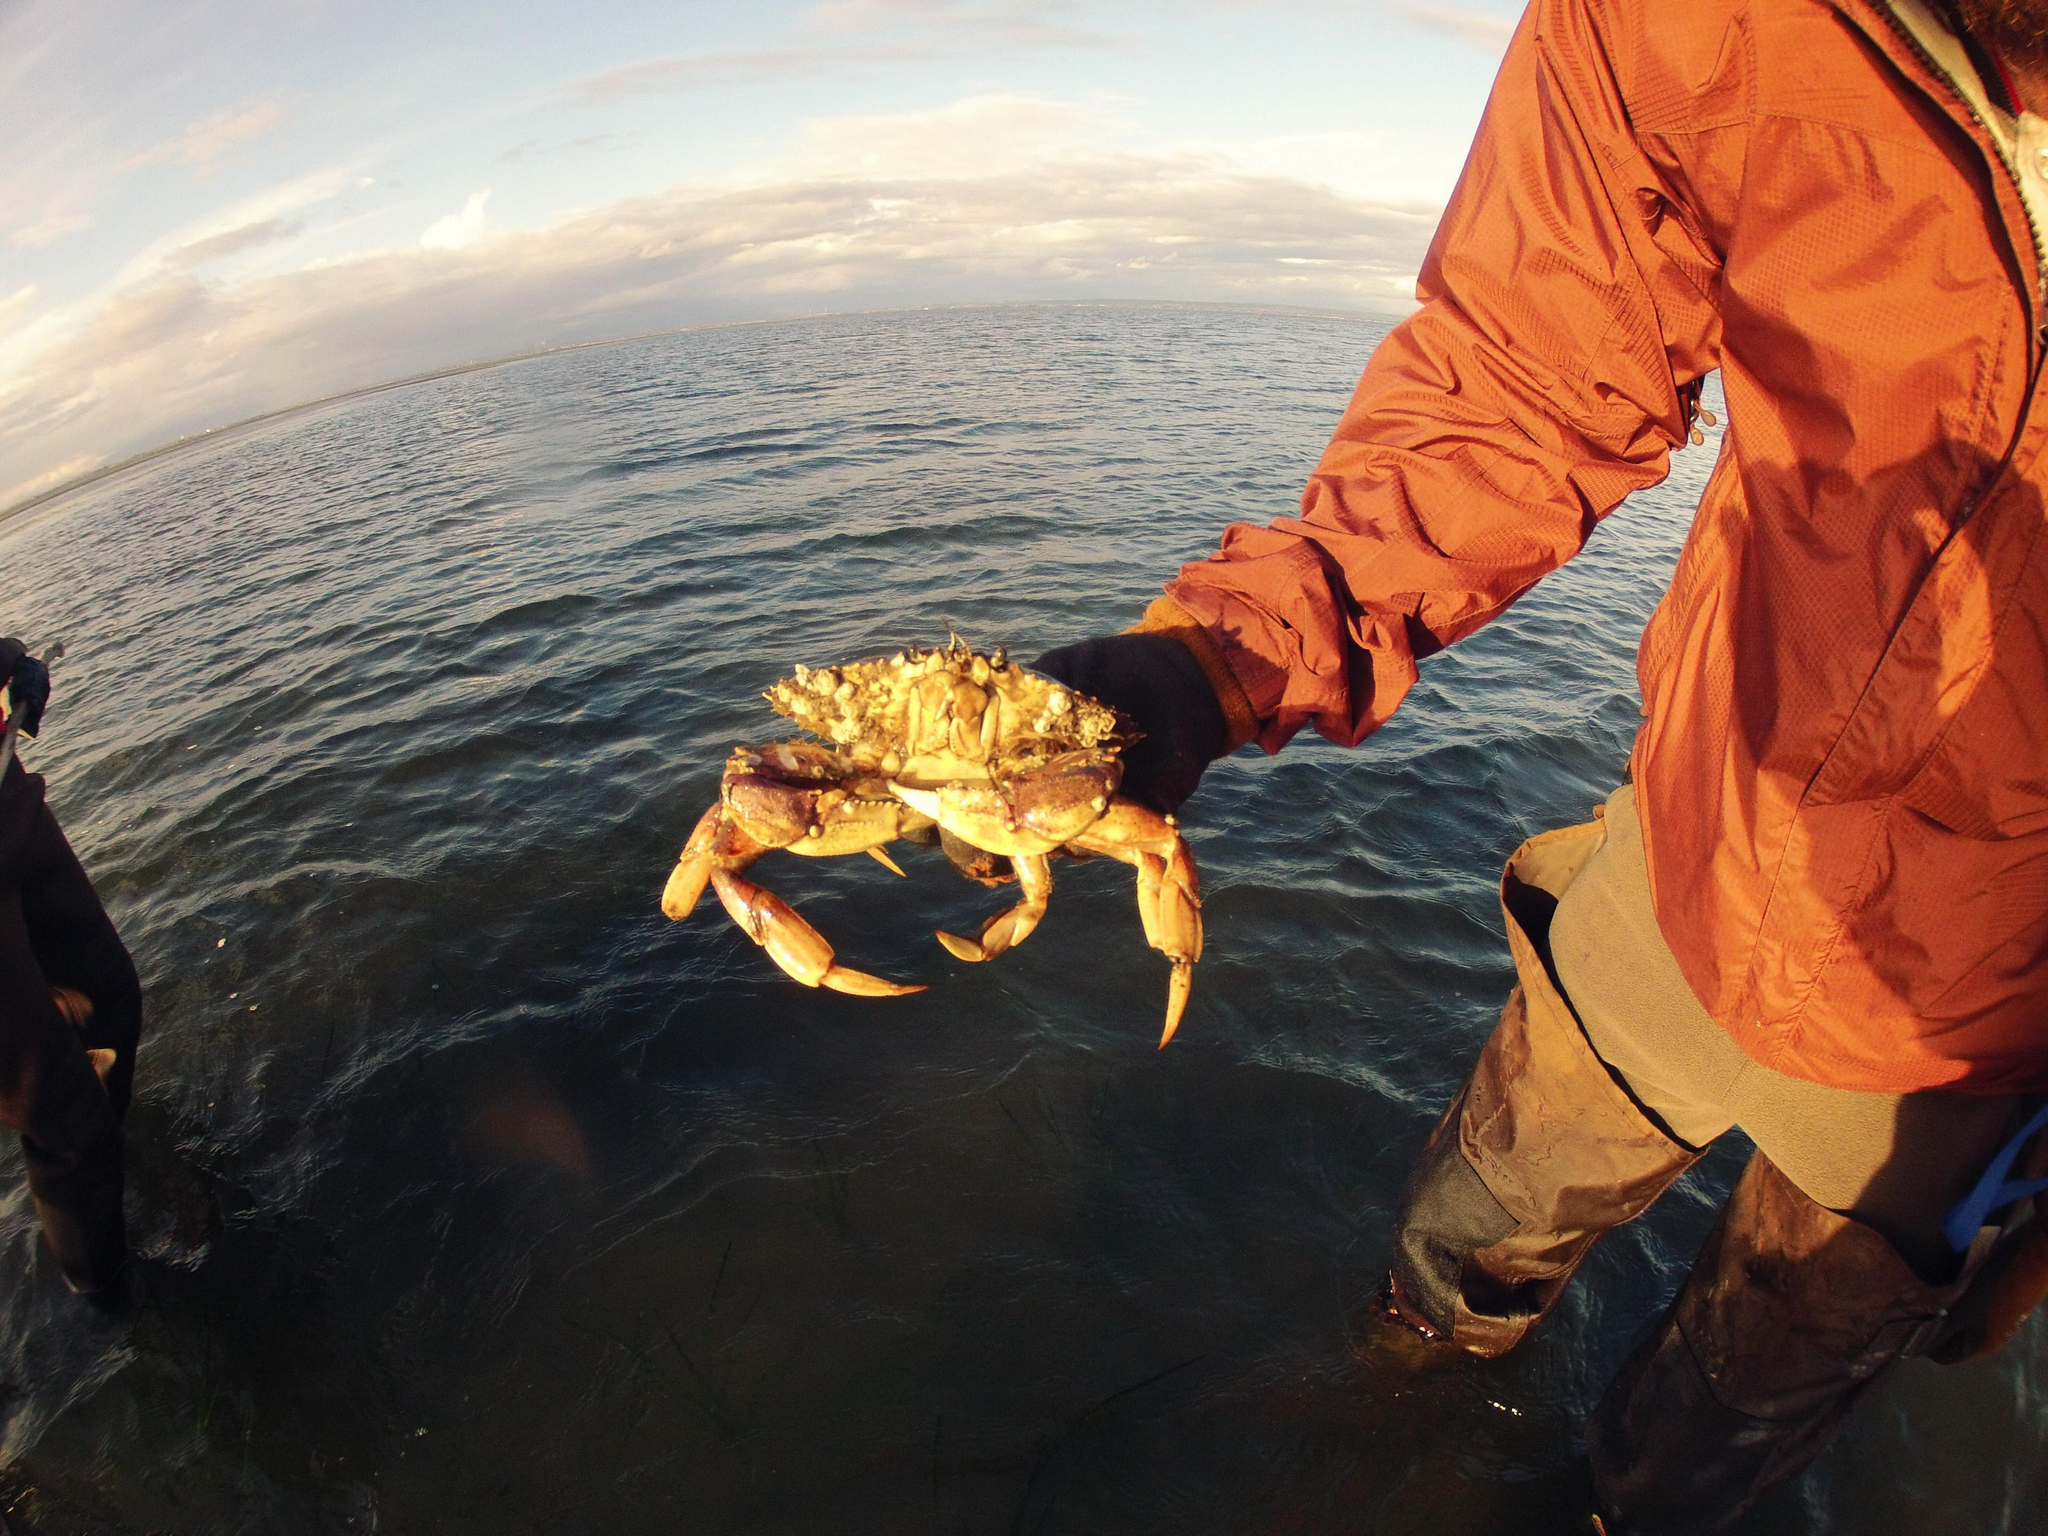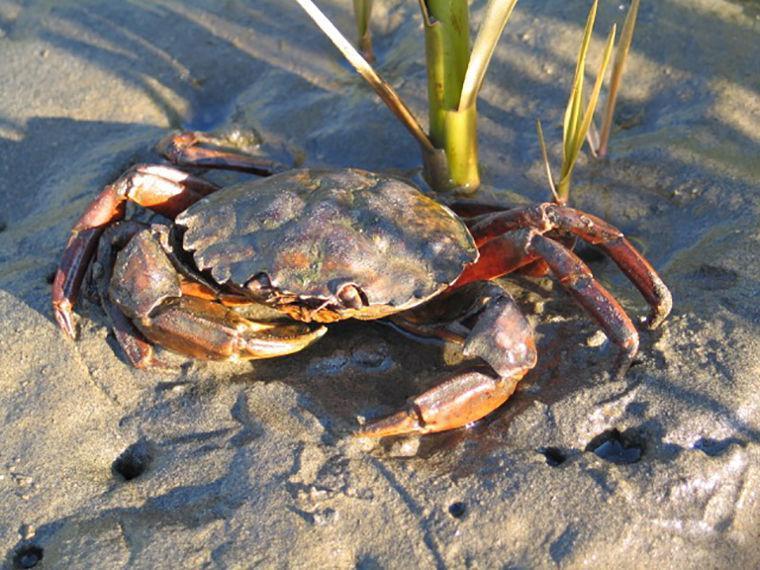The first image is the image on the left, the second image is the image on the right. Given the left and right images, does the statement "In the image to the right, some of the crab's legs are red." hold true? Answer yes or no. Yes. The first image is the image on the left, the second image is the image on the right. Considering the images on both sides, is "Each image shows an angled, forward-facing crab that is not held by a person, but the crab on the left is reddish-purple, and the crab on the right is not." valid? Answer yes or no. No. 